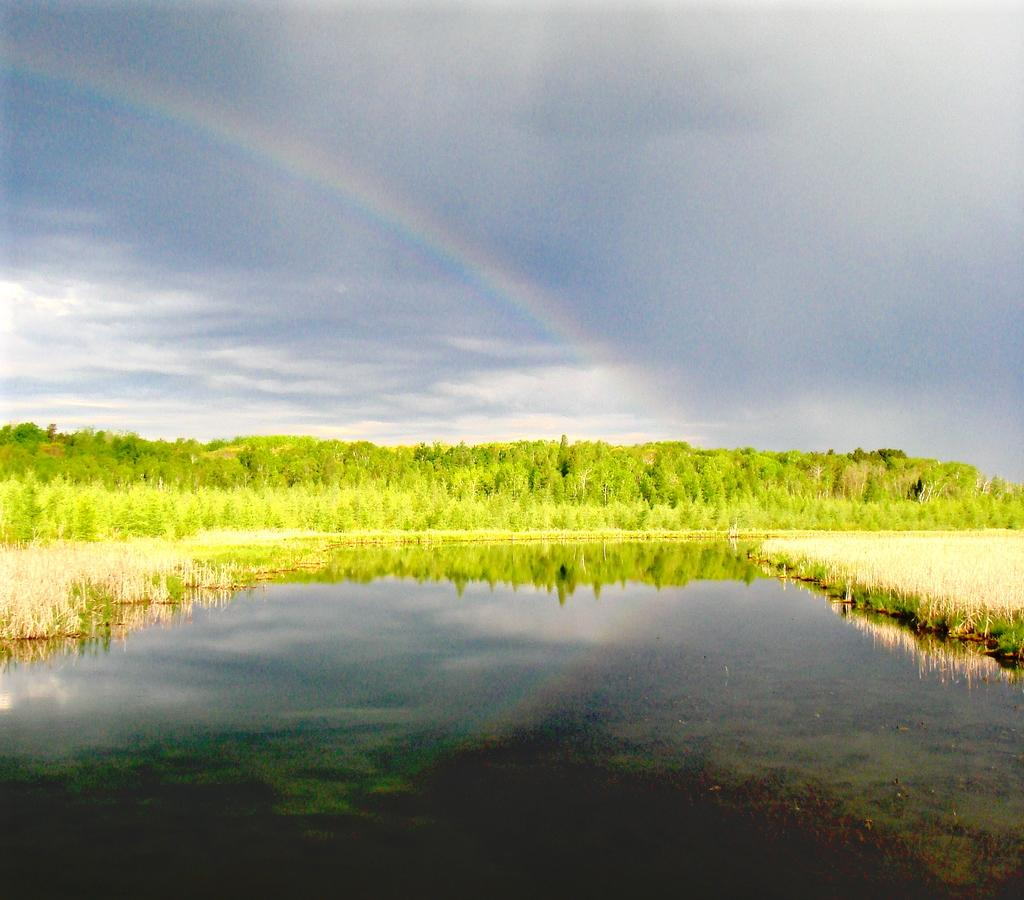What is visible in the image? There is water visible in the image. What can be seen in the background of the image? There are trees in the background of the image. What is the color of the trees? The trees are green in color. What additional feature is present in the image? There is a rainbow in the image. How would you describe the sky in the image? The sky is white and gray in color. What type of pump is visible in the image? There is no pump present in the image. How many quilts are being used to create the rainbow in the image? The rainbow in the image is not created using quilts; it is a natural phenomenon. 